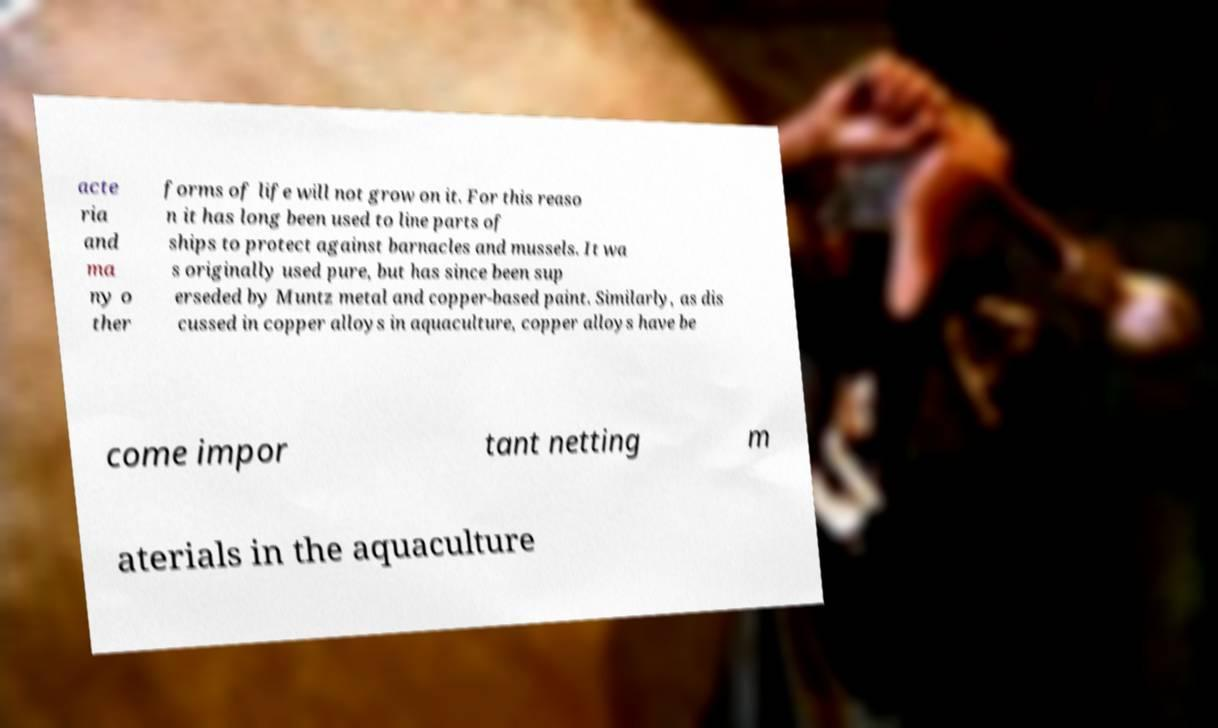There's text embedded in this image that I need extracted. Can you transcribe it verbatim? acte ria and ma ny o ther forms of life will not grow on it. For this reaso n it has long been used to line parts of ships to protect against barnacles and mussels. It wa s originally used pure, but has since been sup erseded by Muntz metal and copper-based paint. Similarly, as dis cussed in copper alloys in aquaculture, copper alloys have be come impor tant netting m aterials in the aquaculture 